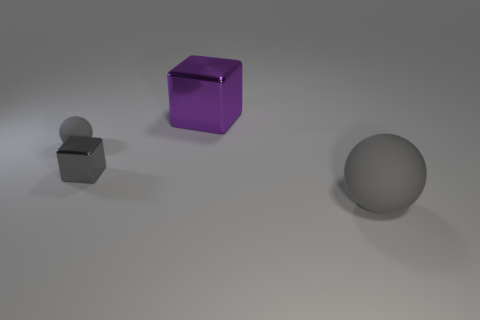What might be the texture of the objects' surface? The surfaces of the objects appear to be smooth and glossy. This can be inferred from the light reflections and highlights on the objects, indicating that they have a reflective and possibly polished finish. 